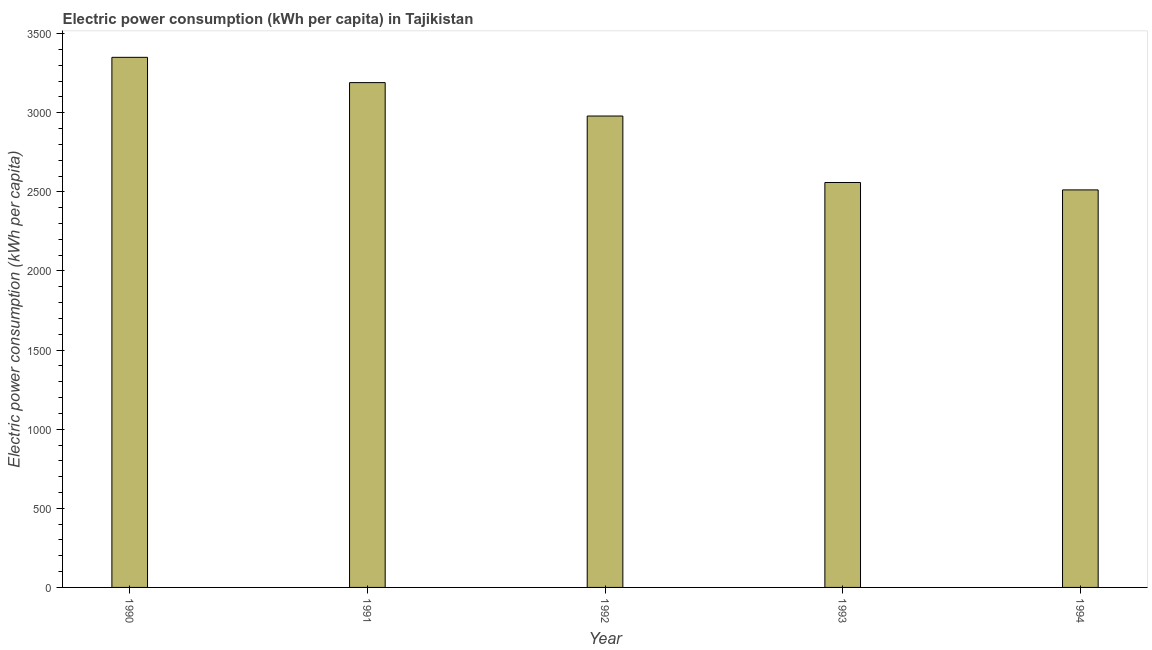Does the graph contain any zero values?
Provide a short and direct response. No. Does the graph contain grids?
Ensure brevity in your answer.  No. What is the title of the graph?
Ensure brevity in your answer.  Electric power consumption (kWh per capita) in Tajikistan. What is the label or title of the Y-axis?
Ensure brevity in your answer.  Electric power consumption (kWh per capita). What is the electric power consumption in 1994?
Make the answer very short. 2512.18. Across all years, what is the maximum electric power consumption?
Give a very brief answer. 3350.02. Across all years, what is the minimum electric power consumption?
Your answer should be compact. 2512.18. In which year was the electric power consumption maximum?
Provide a succinct answer. 1990. In which year was the electric power consumption minimum?
Your answer should be compact. 1994. What is the sum of the electric power consumption?
Give a very brief answer. 1.46e+04. What is the difference between the electric power consumption in 1992 and 1993?
Give a very brief answer. 420.13. What is the average electric power consumption per year?
Ensure brevity in your answer.  2918.08. What is the median electric power consumption?
Offer a terse response. 2979.07. What is the ratio of the electric power consumption in 1992 to that in 1994?
Give a very brief answer. 1.19. Is the difference between the electric power consumption in 1993 and 1994 greater than the difference between any two years?
Make the answer very short. No. What is the difference between the highest and the second highest electric power consumption?
Keep it short and to the point. 159.83. Is the sum of the electric power consumption in 1990 and 1994 greater than the maximum electric power consumption across all years?
Your answer should be compact. Yes. What is the difference between the highest and the lowest electric power consumption?
Offer a terse response. 837.83. Are all the bars in the graph horizontal?
Make the answer very short. No. How many years are there in the graph?
Keep it short and to the point. 5. Are the values on the major ticks of Y-axis written in scientific E-notation?
Give a very brief answer. No. What is the Electric power consumption (kWh per capita) of 1990?
Your answer should be compact. 3350.02. What is the Electric power consumption (kWh per capita) in 1991?
Keep it short and to the point. 3190.19. What is the Electric power consumption (kWh per capita) in 1992?
Give a very brief answer. 2979.07. What is the Electric power consumption (kWh per capita) in 1993?
Ensure brevity in your answer.  2558.93. What is the Electric power consumption (kWh per capita) of 1994?
Provide a succinct answer. 2512.18. What is the difference between the Electric power consumption (kWh per capita) in 1990 and 1991?
Your response must be concise. 159.83. What is the difference between the Electric power consumption (kWh per capita) in 1990 and 1992?
Ensure brevity in your answer.  370.95. What is the difference between the Electric power consumption (kWh per capita) in 1990 and 1993?
Give a very brief answer. 791.09. What is the difference between the Electric power consumption (kWh per capita) in 1990 and 1994?
Provide a succinct answer. 837.83. What is the difference between the Electric power consumption (kWh per capita) in 1991 and 1992?
Provide a succinct answer. 211.12. What is the difference between the Electric power consumption (kWh per capita) in 1991 and 1993?
Your answer should be compact. 631.25. What is the difference between the Electric power consumption (kWh per capita) in 1991 and 1994?
Provide a short and direct response. 678. What is the difference between the Electric power consumption (kWh per capita) in 1992 and 1993?
Provide a succinct answer. 420.13. What is the difference between the Electric power consumption (kWh per capita) in 1992 and 1994?
Your response must be concise. 466.88. What is the difference between the Electric power consumption (kWh per capita) in 1993 and 1994?
Provide a succinct answer. 46.75. What is the ratio of the Electric power consumption (kWh per capita) in 1990 to that in 1992?
Make the answer very short. 1.12. What is the ratio of the Electric power consumption (kWh per capita) in 1990 to that in 1993?
Provide a short and direct response. 1.31. What is the ratio of the Electric power consumption (kWh per capita) in 1990 to that in 1994?
Make the answer very short. 1.33. What is the ratio of the Electric power consumption (kWh per capita) in 1991 to that in 1992?
Make the answer very short. 1.07. What is the ratio of the Electric power consumption (kWh per capita) in 1991 to that in 1993?
Your answer should be very brief. 1.25. What is the ratio of the Electric power consumption (kWh per capita) in 1991 to that in 1994?
Offer a terse response. 1.27. What is the ratio of the Electric power consumption (kWh per capita) in 1992 to that in 1993?
Offer a very short reply. 1.16. What is the ratio of the Electric power consumption (kWh per capita) in 1992 to that in 1994?
Your response must be concise. 1.19. What is the ratio of the Electric power consumption (kWh per capita) in 1993 to that in 1994?
Offer a terse response. 1.02. 